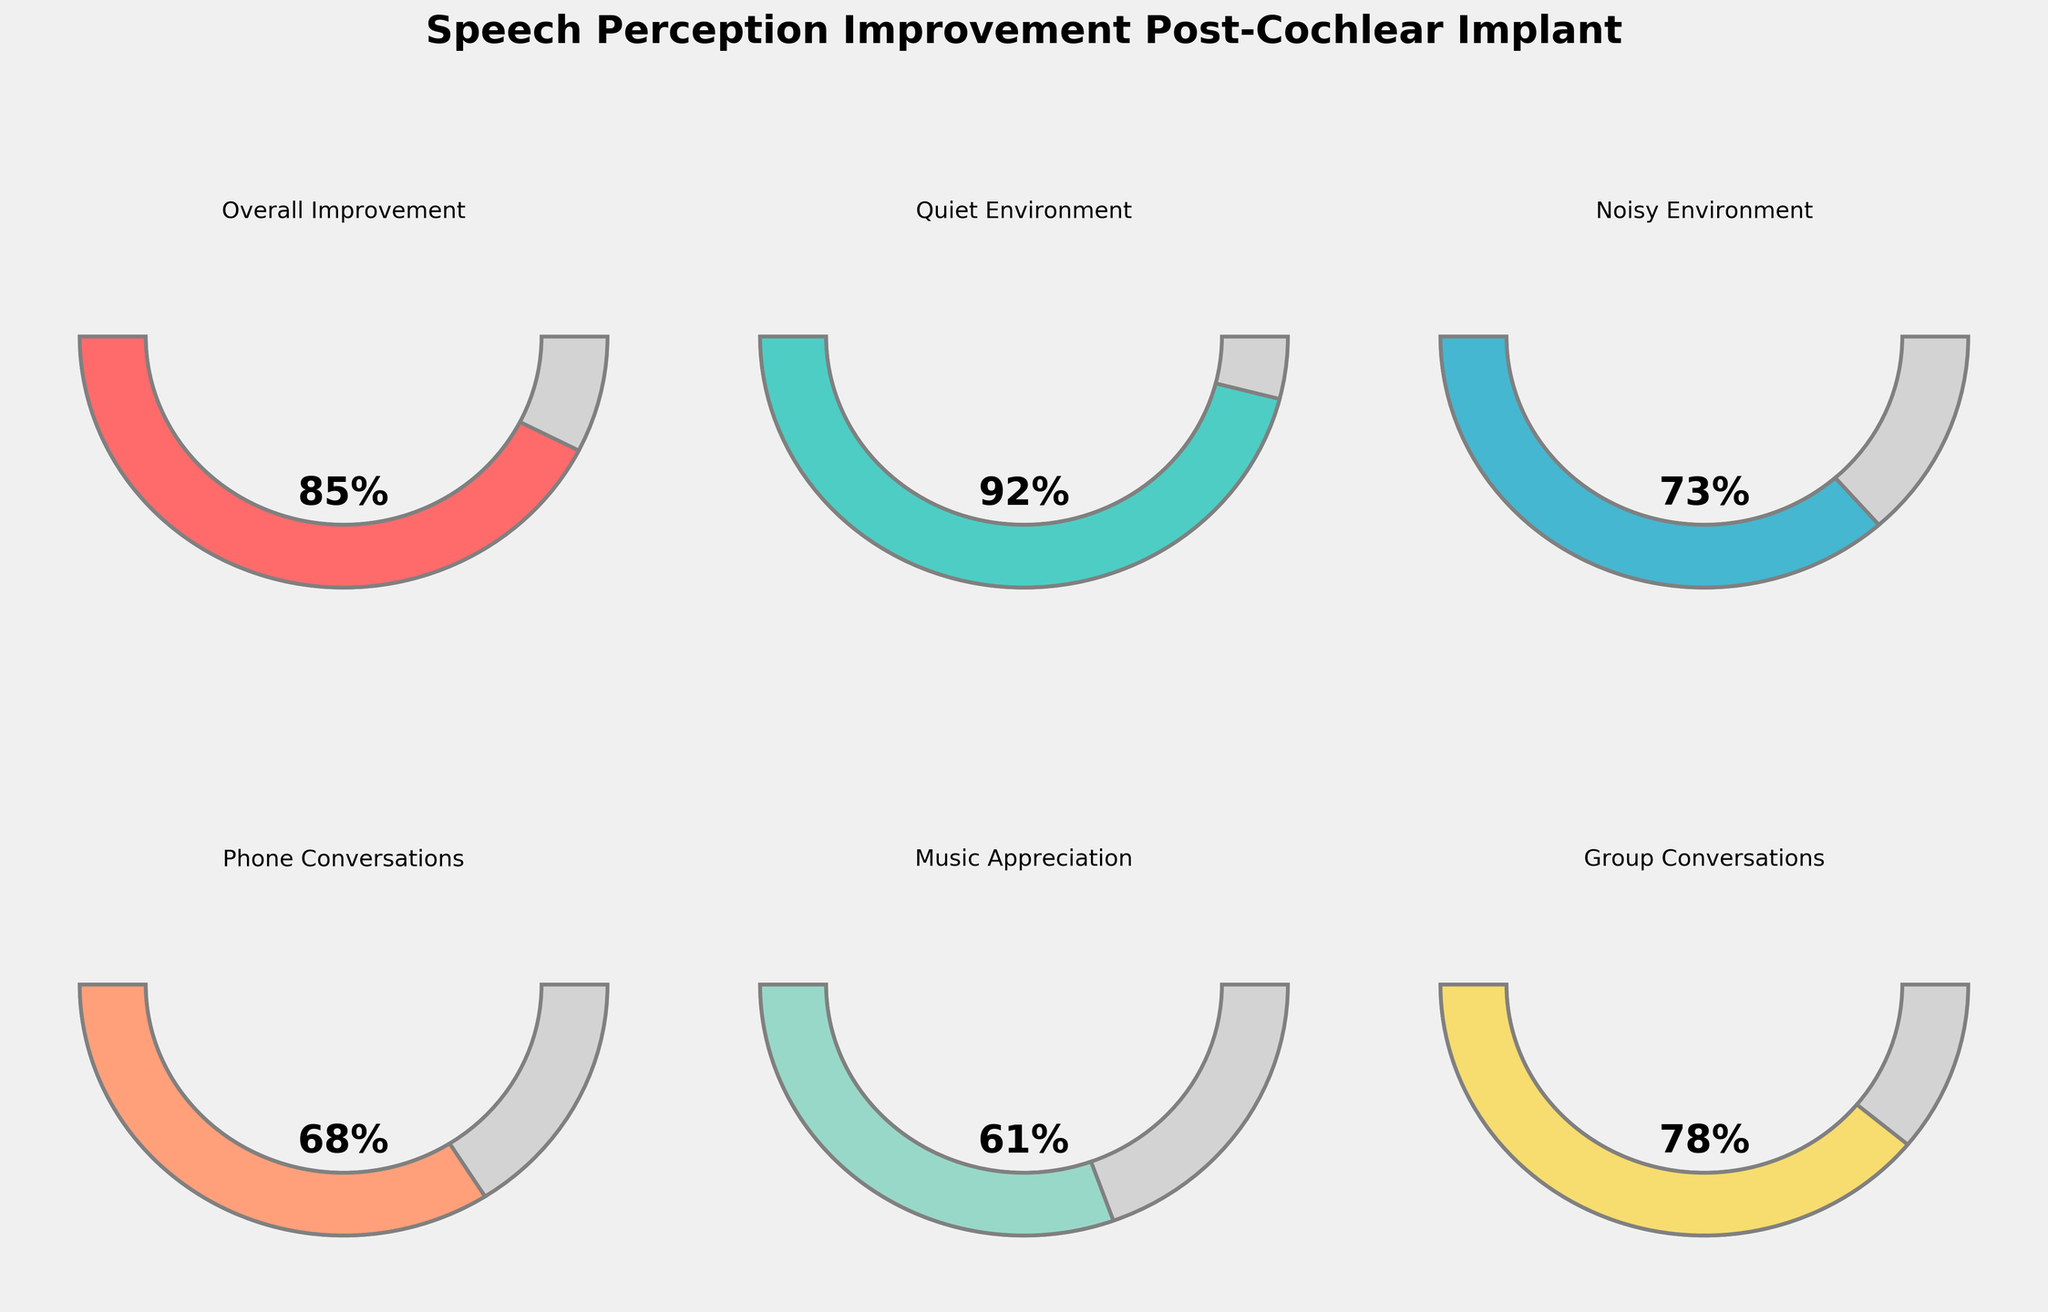What is the overall speech perception improvement percentage post-cochlear implant? Look at the gauge chart labeled 'Overall Improvement'. This chart shows the percentage of improvement which is indicated directly on the gauge.
Answer: 85% Which environment shows the highest percentage of speech perception improvement? Compare all the gauge charts and look for the highest percentage value. 'Quiet Environment' shows the highest improvement with a percentage value of 92%.
Answer: Quiet Environment How much higher is the improvement in a quiet environment compared to group conversations? Subtract the percentage of 'Group Conversations' from 'Quiet Environment'. The respective values are 92% and 78%. So, 92 - 78 = 14.
Answer: 14% Rank the environments from highest to lowest based on speech perception improvement. Arrange the percentages associated with different environments in descending order. The values are: Quiet Environment (92%), Overall Improvement (85%), Group Conversations (78%), Noisy Environment (73%), Phone Conversations (68%), Music Appreciation (61%).
Answer: Quiet Environment, Overall Improvement, Group Conversations, Noisy Environment, Phone Conversations, Music Appreciation What is the average percentage of improvement across all categories? Add all the percentage values and divide by the number of categories. The values are 85, 92, 73, 68, 61, and 78. Sum: 85 + 92 + 73 + 68 + 61 + 78 = 457. Number of categories: 6. Average = 457 / 6 ≈ 76.17.
Answer: 76.17% Which category shows the least improvement in speech perception? Identify the gauge chart with the lowest percentage value. 'Music Appreciation' shows the least improvement with a value of 61%.
Answer: Music Appreciation What’s the difference in speech perception improvement between phone conversations and music appreciation? Subtract the percentage of 'Music Appreciation' from 'Phone Conversations'. The values are 68% and 61% respectively. So, 68 - 61 = 7.
Answer: 7 Between which two categories is the improvement difference of 19 percentage points? Look for pairs of categories where their percentage difference is 19. 'Phone Conversations' (68%) and 'Quiet Environment' (92%) have a difference of 92 - 68 = 24, which does not fit. 'Music Appreciation' (61%) and 'Overall Improvement' (85%) have a difference of 85 - 61 = 24, not fitting either. 'Noisy Environment' (73%) and 'Music Appreciation' (61%) have a difference of 73 - 61 = 12, not fitting. 'Group Conversations' (78%) and 'Noisy Environment' (73%) have a difference of 78 - 73 = 5, not fitting. However, 'Group Conversations' (78%) and 'Phone Conversations' (68%) have a difference of 78 - 68 = 10. None result in exactly 19, hence no such pair exists in the current data set.
Answer: No such pair exists 